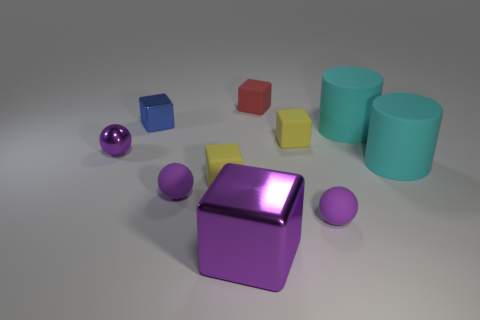Is there a small rubber ball that has the same color as the tiny metallic ball?
Offer a very short reply. Yes. Is there another small object made of the same material as the red object?
Your answer should be very brief. Yes. What is the shape of the yellow thing that is on the left side of the large cube?
Keep it short and to the point. Cube. Does the tiny shiny sphere to the left of the big purple cube have the same color as the large cube?
Offer a terse response. Yes. Are there fewer large purple blocks that are to the right of the red block than big gray shiny spheres?
Your answer should be compact. No. What color is the big object that is made of the same material as the small blue block?
Keep it short and to the point. Purple. How big is the yellow matte cube that is left of the red object?
Your answer should be compact. Small. Are the tiny red block and the blue cube made of the same material?
Provide a succinct answer. No. There is a small metallic ball that is in front of the red matte cube to the right of the purple shiny block; is there a tiny purple metallic sphere to the right of it?
Offer a very short reply. No. The metal ball is what color?
Provide a short and direct response. Purple. 